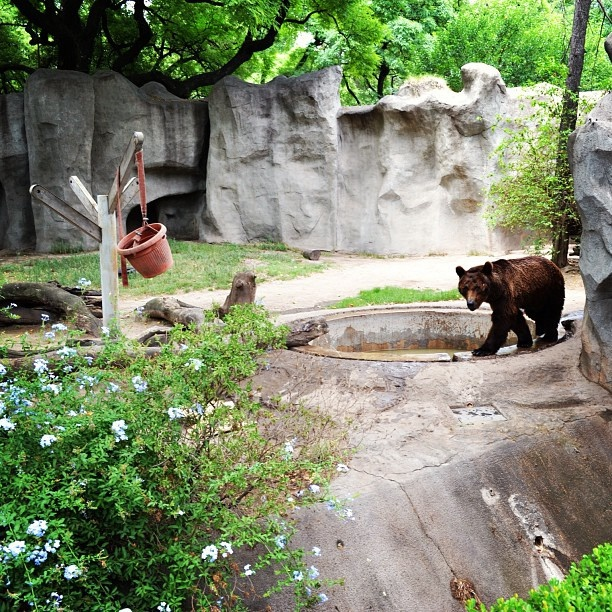Describe the objects in this image and their specific colors. I can see a bear in lime, black, maroon, brown, and gray tones in this image. 